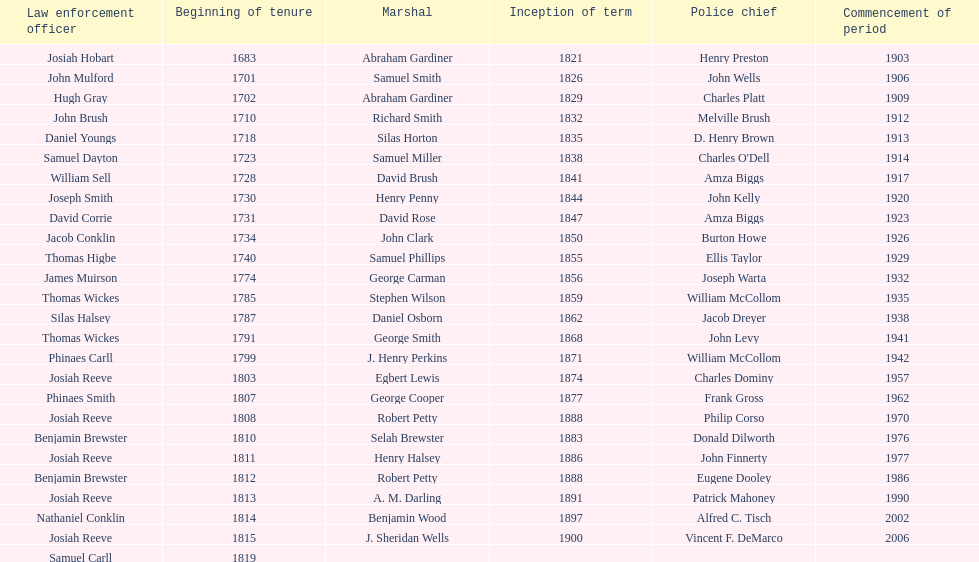What is the number of sheriff's with the last name smith? 5. 